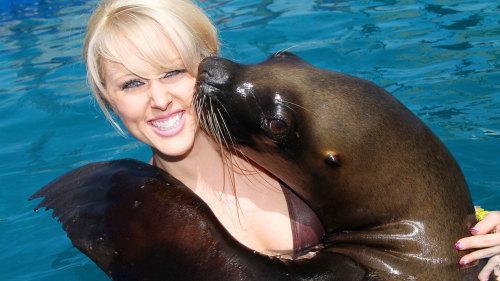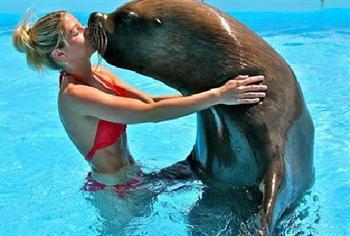The first image is the image on the left, the second image is the image on the right. Considering the images on both sides, is "Two people are in the water with two sea animals in one of the pictures." valid? Answer yes or no. No. The first image is the image on the left, the second image is the image on the right. Assess this claim about the two images: "The right image includes twice the number of people and seals in the foreground as the left image.". Correct or not? Answer yes or no. No. 